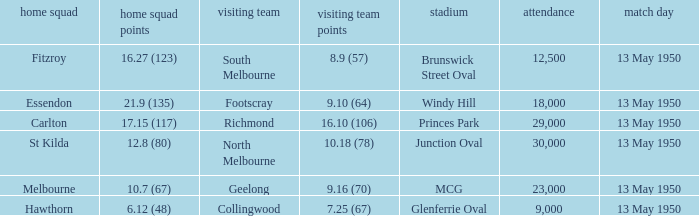What was the away team's score when Fitzroy's score was 16.27 (123) on May 13, 1950. 8.9 (57). 